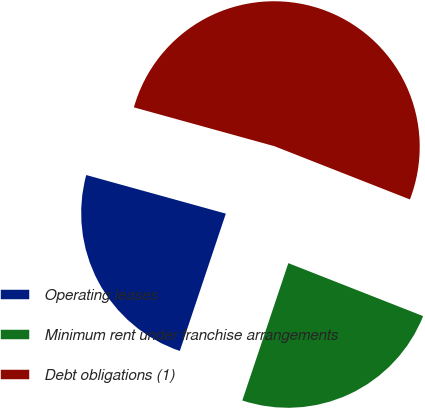<chart> <loc_0><loc_0><loc_500><loc_500><pie_chart><fcel>Operating leases<fcel>Minimum rent under franchise arrangements<fcel>Debt obligations (1)<nl><fcel>24.15%<fcel>24.19%<fcel>51.67%<nl></chart> 